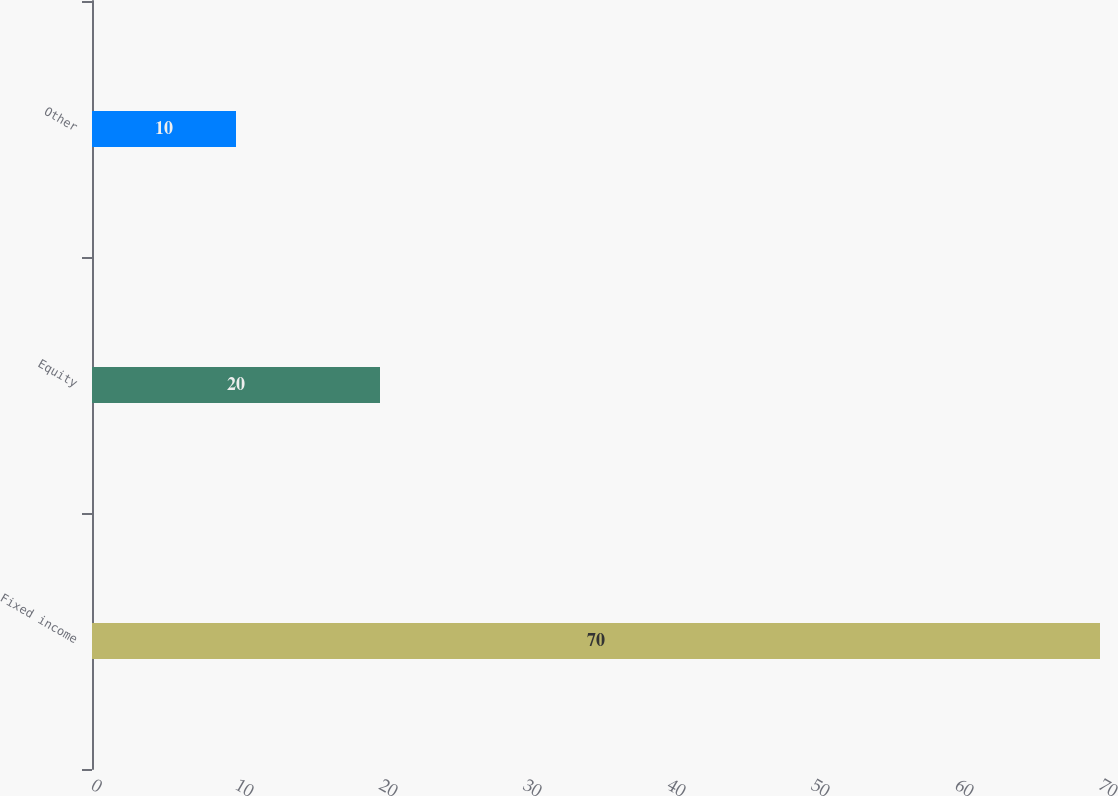Convert chart to OTSL. <chart><loc_0><loc_0><loc_500><loc_500><bar_chart><fcel>Fixed income<fcel>Equity<fcel>Other<nl><fcel>70<fcel>20<fcel>10<nl></chart> 